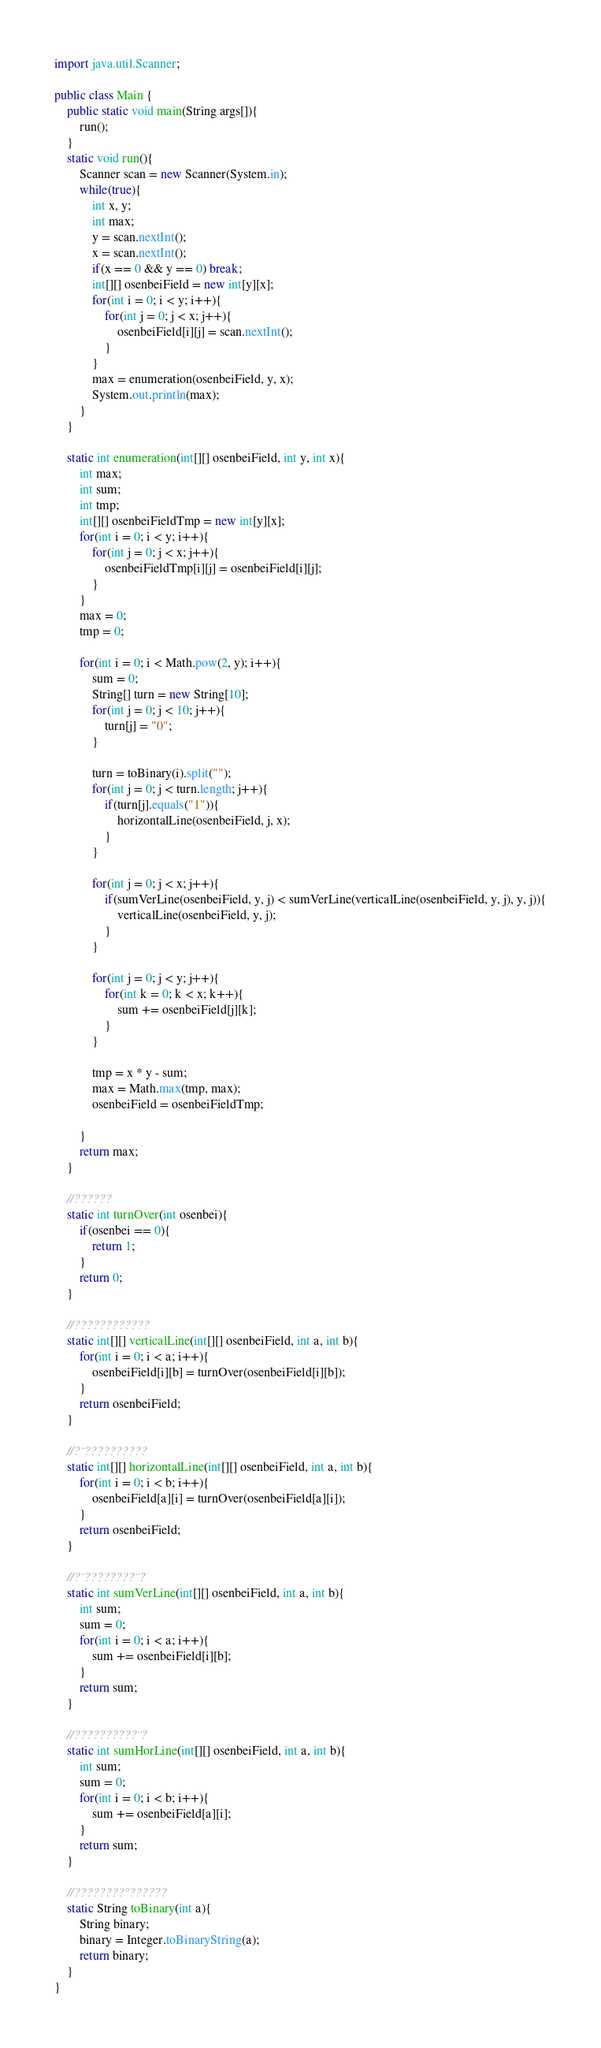Convert code to text. <code><loc_0><loc_0><loc_500><loc_500><_Java_>import java.util.Scanner;

public class Main {
	public static void main(String args[]){
		run();
	}
	static void run(){
		Scanner scan = new Scanner(System.in);
		while(true){
			int x, y;
			int max;
			y = scan.nextInt();
			x = scan.nextInt();
			if(x == 0 && y == 0) break;
			int[][] osenbeiField = new int[y][x];
			for(int i = 0; i < y; i++){
				for(int j = 0; j < x; j++){
					osenbeiField[i][j] = scan.nextInt();
				}
			}
			max = enumeration(osenbeiField, y, x);
			System.out.println(max);
		}
	}
	
	static int enumeration(int[][] osenbeiField, int y, int x){
		int max;
		int sum;
		int tmp;
		int[][] osenbeiFieldTmp = new int[y][x];
		for(int i = 0; i < y; i++){
			for(int j = 0; j < x; j++){
				osenbeiFieldTmp[i][j] = osenbeiField[i][j];
			}
		}
		max = 0;
		tmp = 0;
		
		for(int i = 0; i < Math.pow(2, y); i++){
			sum = 0;
			String[] turn = new String[10];
			for(int j = 0; j < 10; j++){
				turn[j] = "0";
			}
			
			turn = toBinary(i).split("");
			for(int j = 0; j < turn.length; j++){
				if(turn[j].equals("1")){
					horizontalLine(osenbeiField, j, x);
				}
			}

			for(int j = 0; j < x; j++){
				if(sumVerLine(osenbeiField, y, j) < sumVerLine(verticalLine(osenbeiField, y, j), y, j)){
					verticalLine(osenbeiField, y, j);
				}
			}
			
			for(int j = 0; j < y; j++){
				for(int k = 0; k < x; k++){
					sum += osenbeiField[j][k];
				}
			}
			
			tmp = x * y - sum;
			max = Math.max(tmp, max);
			osenbeiField = osenbeiFieldTmp;
			
		}
		return max;
	}
	
	//??????
	static int turnOver(int osenbei){
		if(osenbei == 0){
			return 1;
		}
		return 0;
	}
	
	//????????????
	static int[][] verticalLine(int[][] osenbeiField, int a, int b){
		for(int i = 0; i < a; i++){
			osenbeiField[i][b] = turnOver(osenbeiField[i][b]);
		}
		return osenbeiField;
	}
	
	//?¨??????????
	static int[][] horizontalLine(int[][] osenbeiField, int a, int b){
		for(int i = 0; i < b; i++){
			osenbeiField[a][i] = turnOver(osenbeiField[a][i]);
		}
		return osenbeiField;
	}
	
	//?¨????????¨?
	static int sumVerLine(int[][] osenbeiField, int a, int b){
		int sum;
		sum = 0;
		for(int i = 0; i < a; i++){
			sum += osenbeiField[i][b];
		}
		return sum;
	}
	
	//??????????¨?
	static int sumHorLine(int[][] osenbeiField, int a, int b){
		int sum;
		sum = 0;
		for(int i = 0; i < b; i++){
			sum += osenbeiField[a][i];
		}
		return sum;
	}
	
	//????????°??????
	static String toBinary(int a){
		String binary;
		binary = Integer.toBinaryString(a);
		return binary;
	}
}</code> 